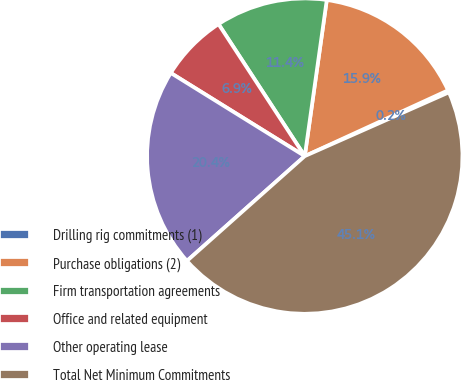Convert chart. <chart><loc_0><loc_0><loc_500><loc_500><pie_chart><fcel>Drilling rig commitments (1)<fcel>Purchase obligations (2)<fcel>Firm transportation agreements<fcel>Office and related equipment<fcel>Other operating lease<fcel>Total Net Minimum Commitments<nl><fcel>0.22%<fcel>15.92%<fcel>11.44%<fcel>6.95%<fcel>20.41%<fcel>45.06%<nl></chart> 